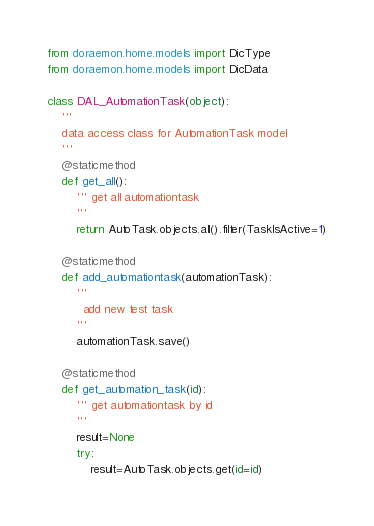Convert code to text. <code><loc_0><loc_0><loc_500><loc_500><_Python_>from doraemon.home.models import DicType
from doraemon.home.models import DicData

class DAL_AutomationTask(object):
    '''
    data access class for AutomationTask model
    '''
    @staticmethod
    def get_all():
        ''' get all automationtask
        '''
        return AutoTask.objects.all().filter(TaskIsActive=1)
    
    @staticmethod
    def add_automationtask(automationTask):
        ''' 
          add new test task
        '''
        automationTask.save()
    
    @staticmethod
    def get_automation_task(id):
        ''' get automationtask by id
        '''
        result=None
        try:
            result=AutoTask.objects.get(id=id)</code> 